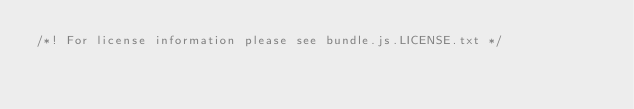<code> <loc_0><loc_0><loc_500><loc_500><_JavaScript_>/*! For license information please see bundle.js.LICENSE.txt */</code> 